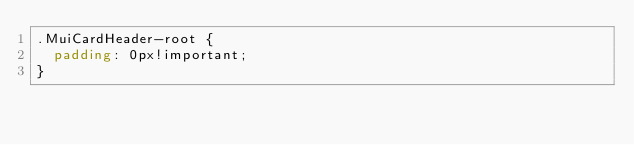Convert code to text. <code><loc_0><loc_0><loc_500><loc_500><_CSS_>.MuiCardHeader-root {
  padding: 0px!important; 
}

</code> 